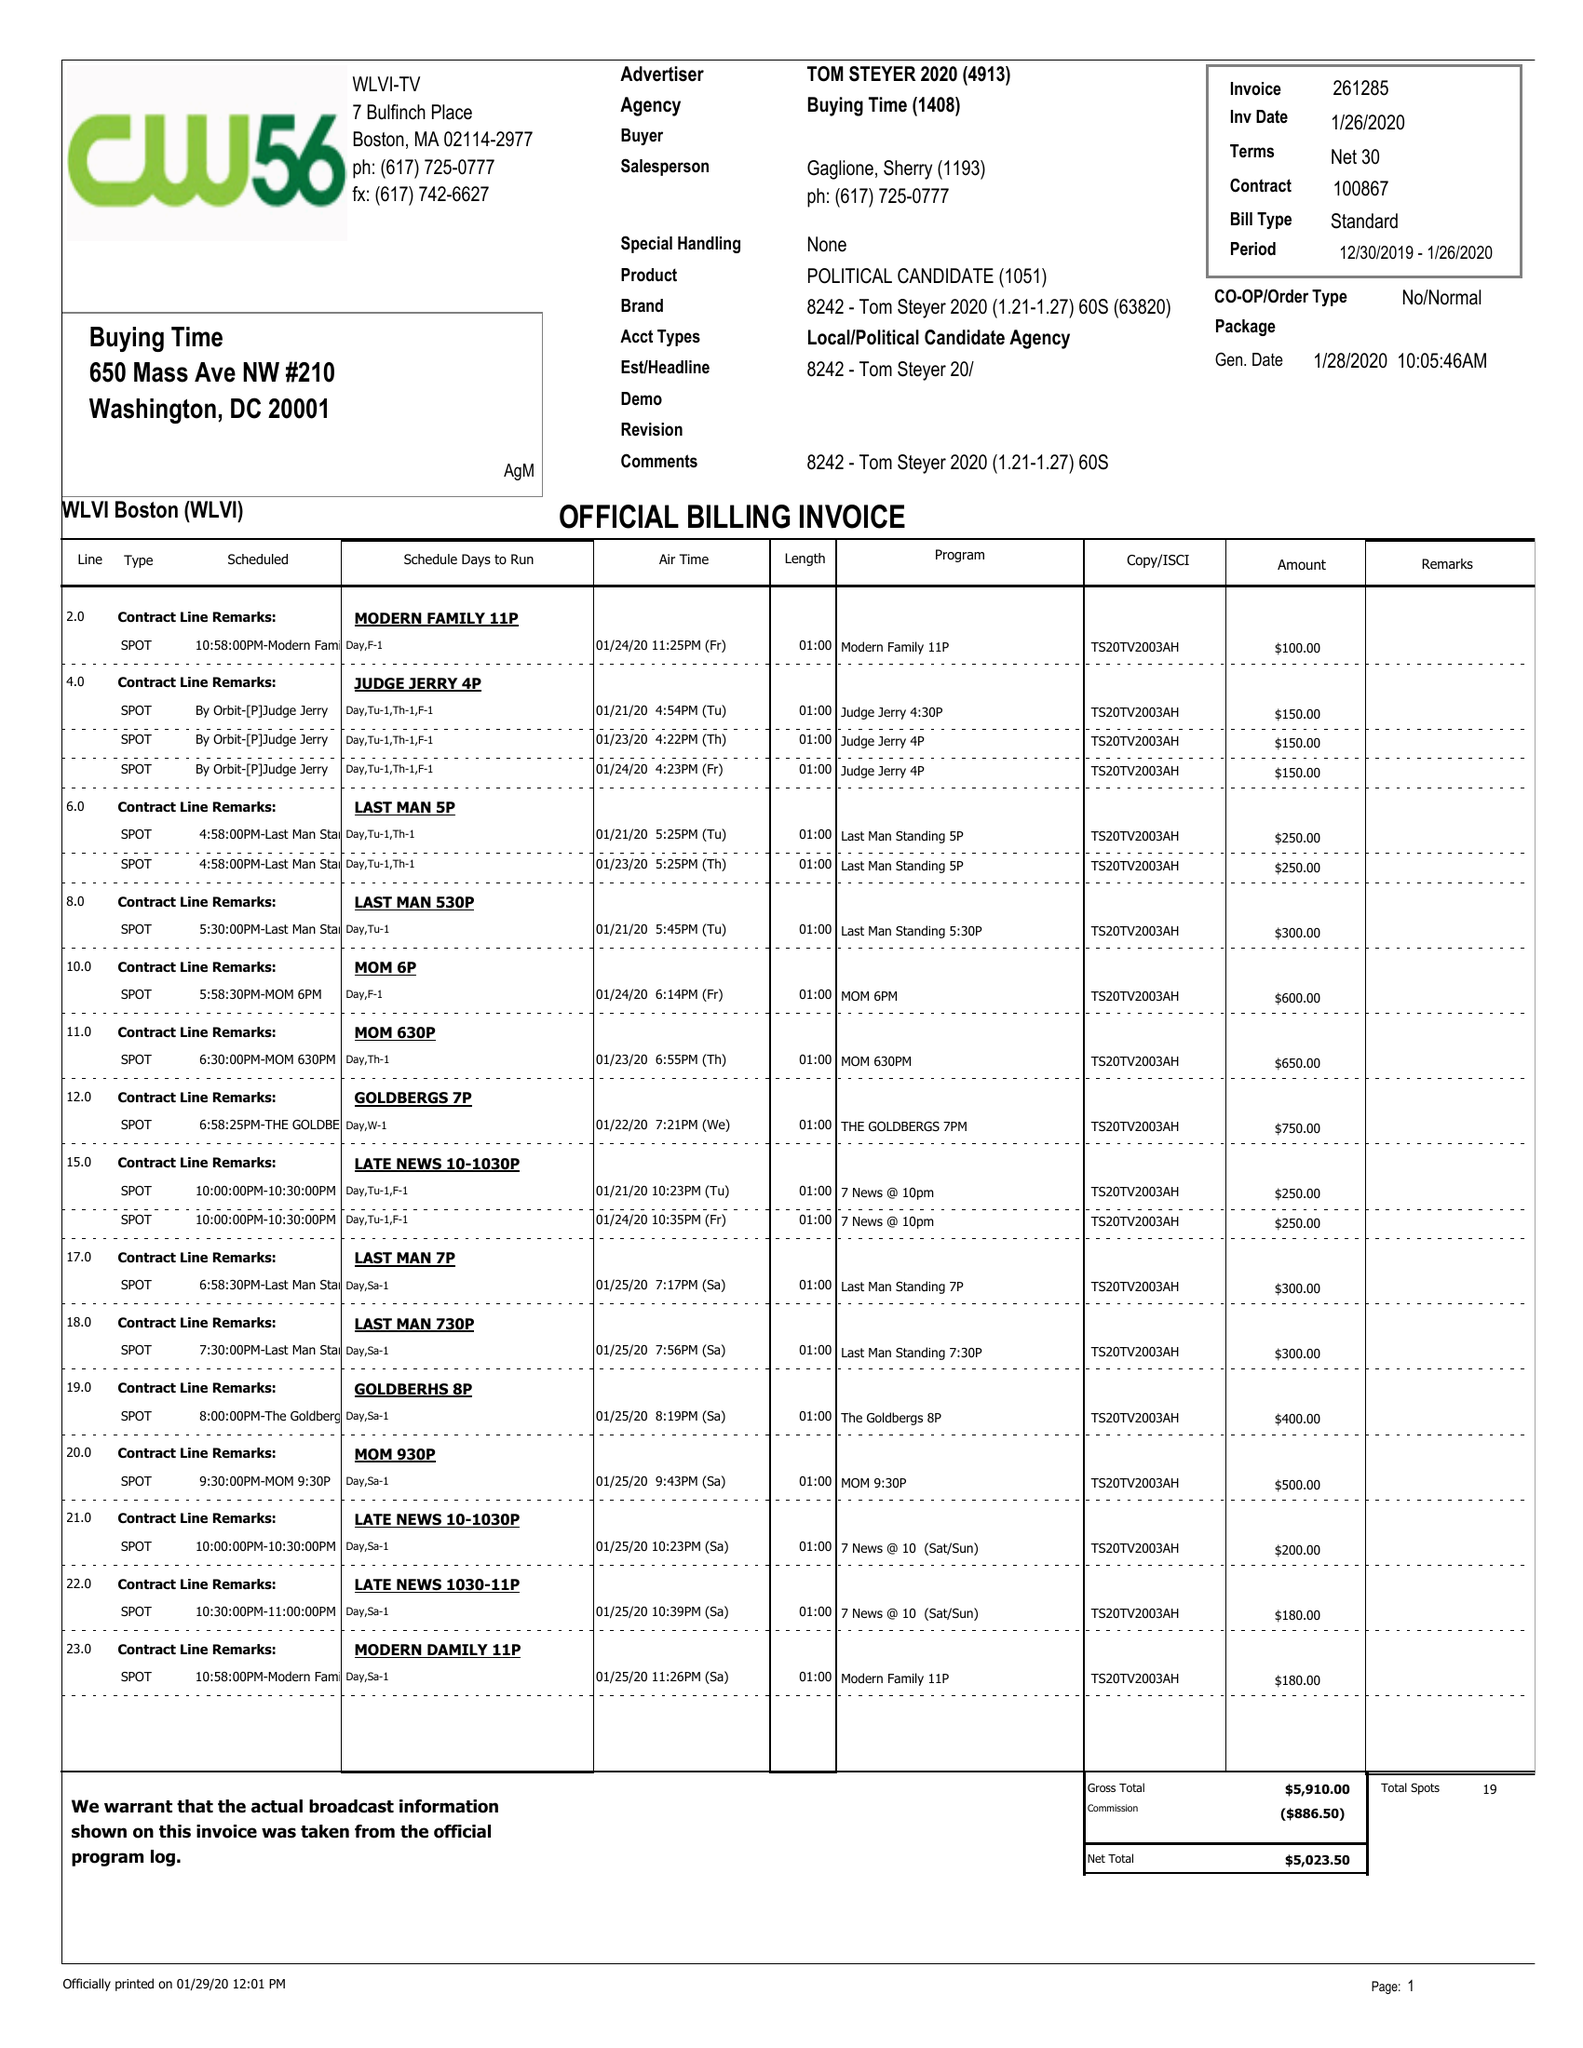What is the value for the gross_amount?
Answer the question using a single word or phrase. 5910.00 